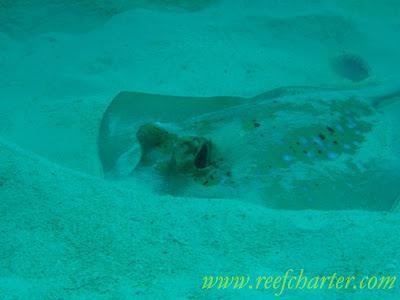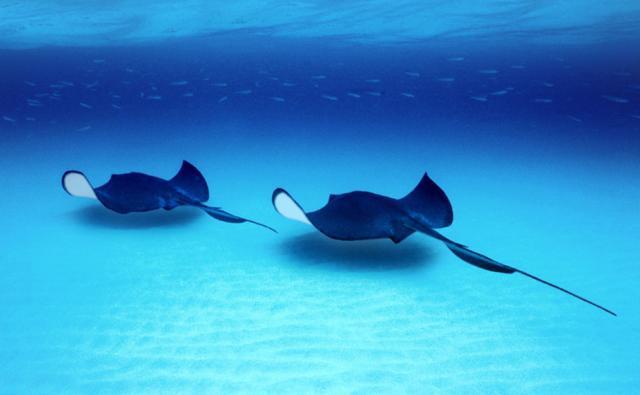The first image is the image on the left, the second image is the image on the right. Considering the images on both sides, is "An image shows one stingray, which is partly submerged in sand." valid? Answer yes or no. Yes. 